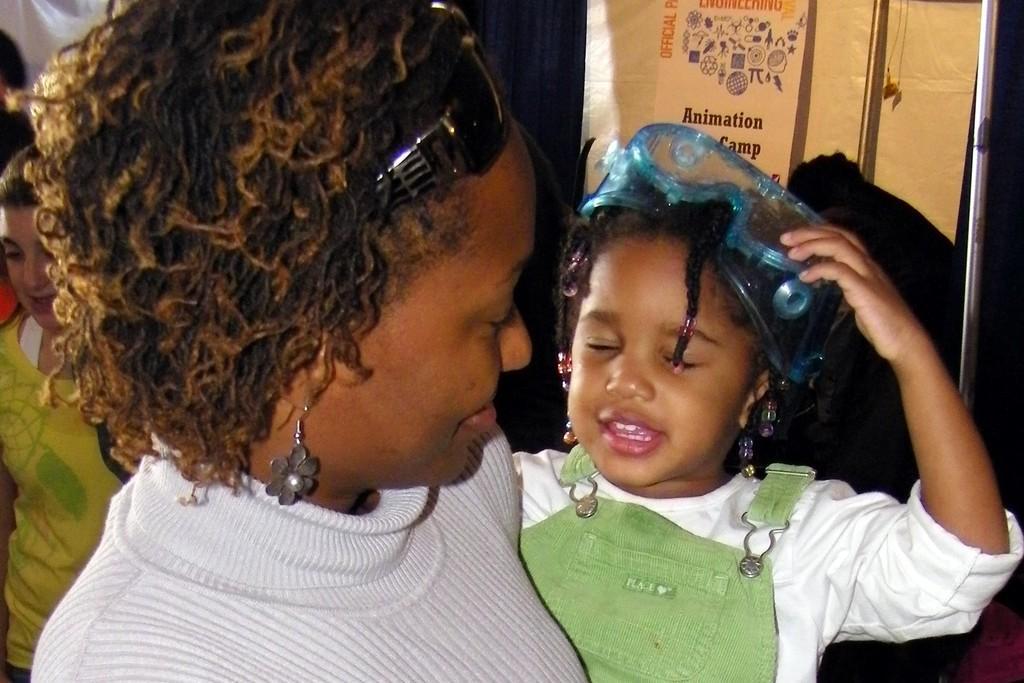In one or two sentences, can you explain what this image depicts? In this image I can see the group of people with white, green and yellow color dresses. I can see one person is wearing the goggles. In the back I can see the banner. 